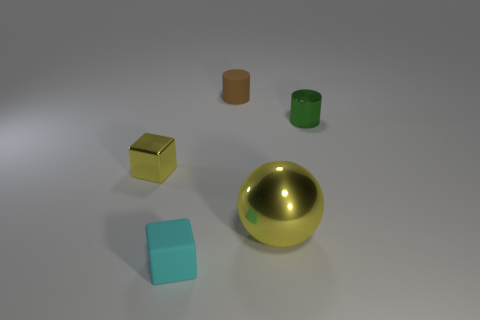Add 2 cyan rubber cylinders. How many objects exist? 7 Subtract all cubes. How many objects are left? 3 Add 5 small green shiny things. How many small green shiny things are left? 6 Add 5 large yellow things. How many large yellow things exist? 6 Subtract 1 brown cylinders. How many objects are left? 4 Subtract all cylinders. Subtract all small blue objects. How many objects are left? 3 